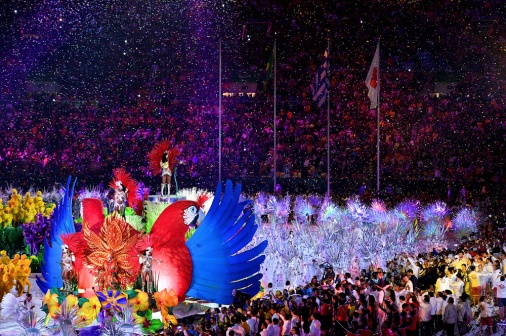Can you describe the mood of the event and the spectators? The mood is undeniably festive and jubilant, with the stadium brimming with energy. Spectators appear to be in high spirits, basking in the visual spectacle before them. Their faces blur together in a collective expression of awe and joy, reflecting the immersive experience of the parade. You can almost hear the cheers and feel the pulse of communal excitement, which is further amplified by the vibrant shower of confetti. 